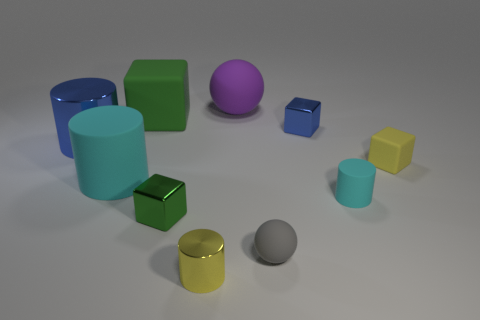Subtract all small metallic cylinders. How many cylinders are left? 3 Subtract all balls. How many objects are left? 8 Subtract all green spheres. How many cyan cylinders are left? 2 Subtract all brown blocks. Subtract all purple cylinders. How many blocks are left? 4 Subtract all blue shiny blocks. Subtract all small green blocks. How many objects are left? 8 Add 7 big purple things. How many big purple things are left? 8 Add 8 rubber cubes. How many rubber cubes exist? 10 Subtract all yellow blocks. How many blocks are left? 3 Subtract 0 purple cubes. How many objects are left? 10 Subtract 1 spheres. How many spheres are left? 1 